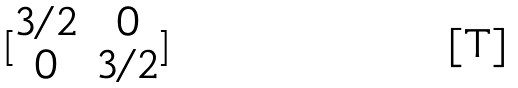Convert formula to latex. <formula><loc_0><loc_0><loc_500><loc_500>[ \begin{matrix} 3 / 2 & 0 \\ 0 & 3 / 2 \end{matrix} ]</formula> 